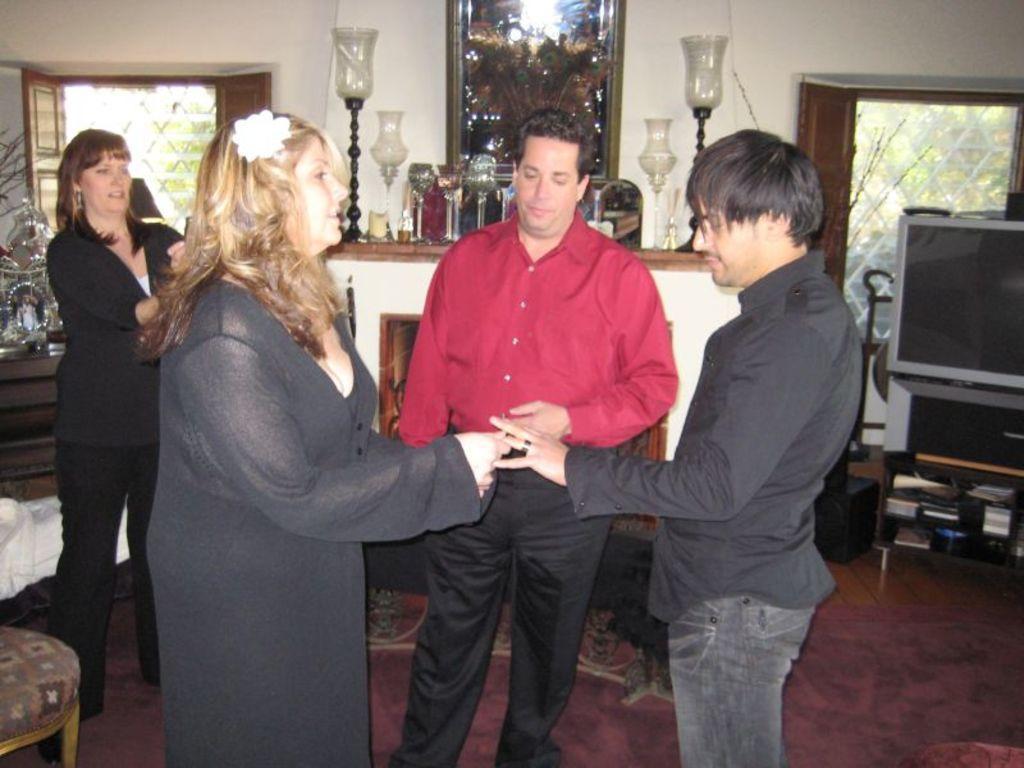Describe this image in one or two sentences. In this image we can see men and women standing on the floor. In the background there are decors, candle holders, beverage glasses, television set, books arranged in the racks, chairs, windows and a wall hanging to the wall. 